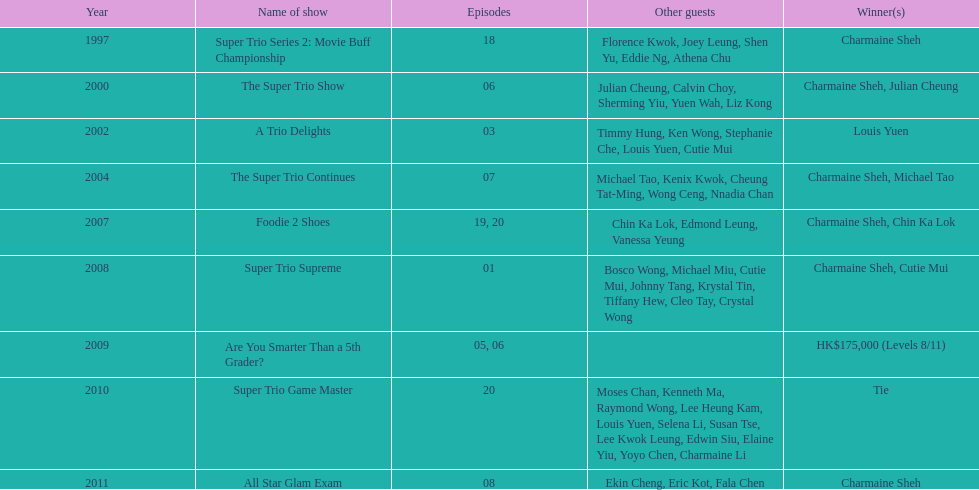How many consecutive trio shows did charmaine sheh do before being on another variety program? 34. 